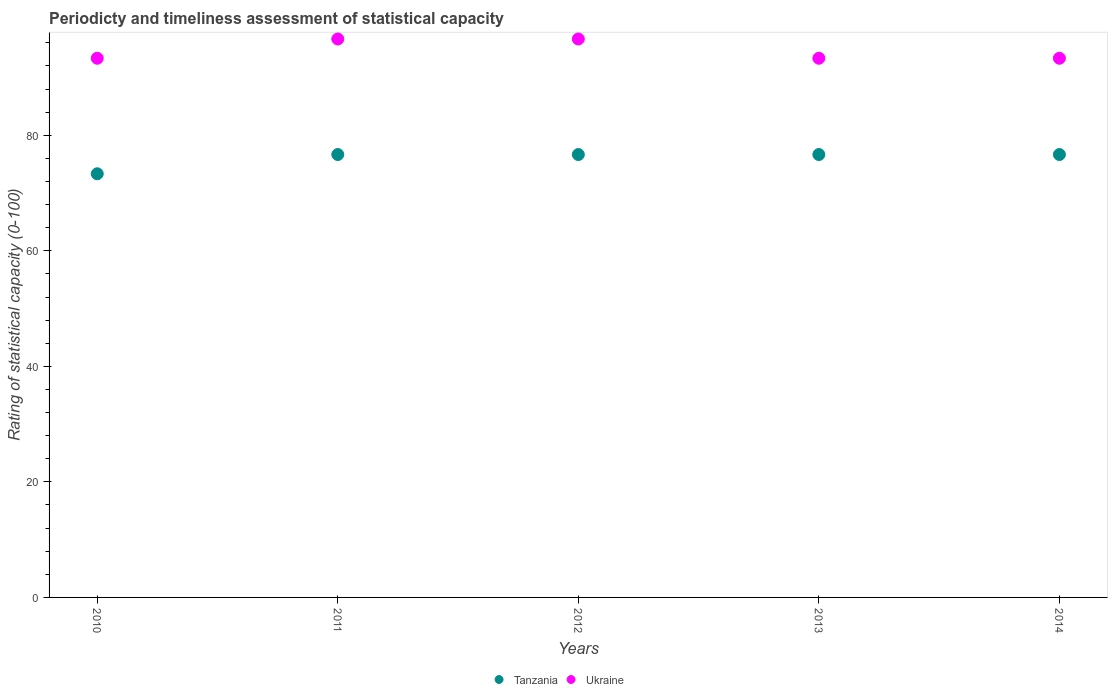Is the number of dotlines equal to the number of legend labels?
Offer a very short reply. Yes. What is the rating of statistical capacity in Tanzania in 2012?
Your answer should be compact. 76.67. Across all years, what is the maximum rating of statistical capacity in Tanzania?
Keep it short and to the point. 76.67. Across all years, what is the minimum rating of statistical capacity in Ukraine?
Your response must be concise. 93.33. In which year was the rating of statistical capacity in Ukraine maximum?
Your response must be concise. 2011. What is the total rating of statistical capacity in Ukraine in the graph?
Ensure brevity in your answer.  473.33. What is the difference between the rating of statistical capacity in Tanzania in 2010 and that in 2013?
Your answer should be very brief. -3.33. What is the difference between the rating of statistical capacity in Ukraine in 2010 and the rating of statistical capacity in Tanzania in 2012?
Keep it short and to the point. 16.67. What is the average rating of statistical capacity in Tanzania per year?
Provide a succinct answer. 76. What is the ratio of the rating of statistical capacity in Ukraine in 2010 to that in 2014?
Make the answer very short. 1. What is the difference between the highest and the second highest rating of statistical capacity in Ukraine?
Offer a very short reply. 0. What is the difference between the highest and the lowest rating of statistical capacity in Tanzania?
Your answer should be compact. 3.33. In how many years, is the rating of statistical capacity in Tanzania greater than the average rating of statistical capacity in Tanzania taken over all years?
Your response must be concise. 4. Is the sum of the rating of statistical capacity in Ukraine in 2011 and 2012 greater than the maximum rating of statistical capacity in Tanzania across all years?
Keep it short and to the point. Yes. Is the rating of statistical capacity in Tanzania strictly less than the rating of statistical capacity in Ukraine over the years?
Your response must be concise. Yes. How many dotlines are there?
Your answer should be compact. 2. What is the title of the graph?
Offer a very short reply. Periodicty and timeliness assessment of statistical capacity. Does "Mongolia" appear as one of the legend labels in the graph?
Your answer should be very brief. No. What is the label or title of the X-axis?
Your answer should be very brief. Years. What is the label or title of the Y-axis?
Your answer should be compact. Rating of statistical capacity (0-100). What is the Rating of statistical capacity (0-100) in Tanzania in 2010?
Provide a short and direct response. 73.33. What is the Rating of statistical capacity (0-100) of Ukraine in 2010?
Give a very brief answer. 93.33. What is the Rating of statistical capacity (0-100) of Tanzania in 2011?
Offer a very short reply. 76.67. What is the Rating of statistical capacity (0-100) of Ukraine in 2011?
Offer a very short reply. 96.67. What is the Rating of statistical capacity (0-100) of Tanzania in 2012?
Provide a short and direct response. 76.67. What is the Rating of statistical capacity (0-100) of Ukraine in 2012?
Provide a succinct answer. 96.67. What is the Rating of statistical capacity (0-100) in Tanzania in 2013?
Offer a very short reply. 76.67. What is the Rating of statistical capacity (0-100) of Ukraine in 2013?
Provide a short and direct response. 93.33. What is the Rating of statistical capacity (0-100) of Tanzania in 2014?
Your response must be concise. 76.67. What is the Rating of statistical capacity (0-100) of Ukraine in 2014?
Offer a terse response. 93.33. Across all years, what is the maximum Rating of statistical capacity (0-100) in Tanzania?
Your answer should be very brief. 76.67. Across all years, what is the maximum Rating of statistical capacity (0-100) in Ukraine?
Give a very brief answer. 96.67. Across all years, what is the minimum Rating of statistical capacity (0-100) of Tanzania?
Your answer should be compact. 73.33. Across all years, what is the minimum Rating of statistical capacity (0-100) of Ukraine?
Your response must be concise. 93.33. What is the total Rating of statistical capacity (0-100) of Tanzania in the graph?
Provide a short and direct response. 380. What is the total Rating of statistical capacity (0-100) in Ukraine in the graph?
Provide a succinct answer. 473.33. What is the difference between the Rating of statistical capacity (0-100) of Ukraine in 2010 and that in 2011?
Give a very brief answer. -3.33. What is the difference between the Rating of statistical capacity (0-100) of Tanzania in 2010 and that in 2012?
Provide a succinct answer. -3.33. What is the difference between the Rating of statistical capacity (0-100) of Tanzania in 2010 and that in 2014?
Your response must be concise. -3.33. What is the difference between the Rating of statistical capacity (0-100) in Ukraine in 2010 and that in 2014?
Keep it short and to the point. -0. What is the difference between the Rating of statistical capacity (0-100) of Tanzania in 2011 and that in 2012?
Provide a succinct answer. 0. What is the difference between the Rating of statistical capacity (0-100) of Ukraine in 2011 and that in 2012?
Offer a very short reply. 0. What is the difference between the Rating of statistical capacity (0-100) in Tanzania in 2011 and that in 2013?
Give a very brief answer. 0. What is the difference between the Rating of statistical capacity (0-100) of Ukraine in 2011 and that in 2013?
Your answer should be very brief. 3.33. What is the difference between the Rating of statistical capacity (0-100) of Ukraine in 2012 and that in 2013?
Keep it short and to the point. 3.33. What is the difference between the Rating of statistical capacity (0-100) in Tanzania in 2012 and that in 2014?
Make the answer very short. 0. What is the difference between the Rating of statistical capacity (0-100) in Tanzania in 2013 and that in 2014?
Offer a terse response. 0. What is the difference between the Rating of statistical capacity (0-100) in Tanzania in 2010 and the Rating of statistical capacity (0-100) in Ukraine in 2011?
Offer a terse response. -23.33. What is the difference between the Rating of statistical capacity (0-100) in Tanzania in 2010 and the Rating of statistical capacity (0-100) in Ukraine in 2012?
Keep it short and to the point. -23.33. What is the difference between the Rating of statistical capacity (0-100) in Tanzania in 2010 and the Rating of statistical capacity (0-100) in Ukraine in 2013?
Offer a terse response. -20. What is the difference between the Rating of statistical capacity (0-100) of Tanzania in 2011 and the Rating of statistical capacity (0-100) of Ukraine in 2013?
Make the answer very short. -16.67. What is the difference between the Rating of statistical capacity (0-100) of Tanzania in 2011 and the Rating of statistical capacity (0-100) of Ukraine in 2014?
Your answer should be very brief. -16.67. What is the difference between the Rating of statistical capacity (0-100) of Tanzania in 2012 and the Rating of statistical capacity (0-100) of Ukraine in 2013?
Ensure brevity in your answer.  -16.67. What is the difference between the Rating of statistical capacity (0-100) of Tanzania in 2012 and the Rating of statistical capacity (0-100) of Ukraine in 2014?
Give a very brief answer. -16.67. What is the difference between the Rating of statistical capacity (0-100) of Tanzania in 2013 and the Rating of statistical capacity (0-100) of Ukraine in 2014?
Offer a terse response. -16.67. What is the average Rating of statistical capacity (0-100) in Tanzania per year?
Ensure brevity in your answer.  76. What is the average Rating of statistical capacity (0-100) of Ukraine per year?
Provide a succinct answer. 94.67. In the year 2010, what is the difference between the Rating of statistical capacity (0-100) of Tanzania and Rating of statistical capacity (0-100) of Ukraine?
Ensure brevity in your answer.  -20. In the year 2013, what is the difference between the Rating of statistical capacity (0-100) in Tanzania and Rating of statistical capacity (0-100) in Ukraine?
Give a very brief answer. -16.67. In the year 2014, what is the difference between the Rating of statistical capacity (0-100) in Tanzania and Rating of statistical capacity (0-100) in Ukraine?
Make the answer very short. -16.67. What is the ratio of the Rating of statistical capacity (0-100) in Tanzania in 2010 to that in 2011?
Your answer should be very brief. 0.96. What is the ratio of the Rating of statistical capacity (0-100) of Ukraine in 2010 to that in 2011?
Provide a short and direct response. 0.97. What is the ratio of the Rating of statistical capacity (0-100) in Tanzania in 2010 to that in 2012?
Provide a succinct answer. 0.96. What is the ratio of the Rating of statistical capacity (0-100) of Ukraine in 2010 to that in 2012?
Give a very brief answer. 0.97. What is the ratio of the Rating of statistical capacity (0-100) of Tanzania in 2010 to that in 2013?
Provide a succinct answer. 0.96. What is the ratio of the Rating of statistical capacity (0-100) of Ukraine in 2010 to that in 2013?
Offer a very short reply. 1. What is the ratio of the Rating of statistical capacity (0-100) in Tanzania in 2010 to that in 2014?
Keep it short and to the point. 0.96. What is the ratio of the Rating of statistical capacity (0-100) of Ukraine in 2010 to that in 2014?
Offer a very short reply. 1. What is the ratio of the Rating of statistical capacity (0-100) in Ukraine in 2011 to that in 2012?
Make the answer very short. 1. What is the ratio of the Rating of statistical capacity (0-100) in Tanzania in 2011 to that in 2013?
Keep it short and to the point. 1. What is the ratio of the Rating of statistical capacity (0-100) of Ukraine in 2011 to that in 2013?
Keep it short and to the point. 1.04. What is the ratio of the Rating of statistical capacity (0-100) of Tanzania in 2011 to that in 2014?
Ensure brevity in your answer.  1. What is the ratio of the Rating of statistical capacity (0-100) of Ukraine in 2011 to that in 2014?
Offer a very short reply. 1.04. What is the ratio of the Rating of statistical capacity (0-100) of Ukraine in 2012 to that in 2013?
Keep it short and to the point. 1.04. What is the ratio of the Rating of statistical capacity (0-100) in Tanzania in 2012 to that in 2014?
Your answer should be very brief. 1. What is the ratio of the Rating of statistical capacity (0-100) in Ukraine in 2012 to that in 2014?
Your answer should be very brief. 1.04. What is the difference between the highest and the second highest Rating of statistical capacity (0-100) of Ukraine?
Your answer should be compact. 0. What is the difference between the highest and the lowest Rating of statistical capacity (0-100) of Tanzania?
Give a very brief answer. 3.33. 